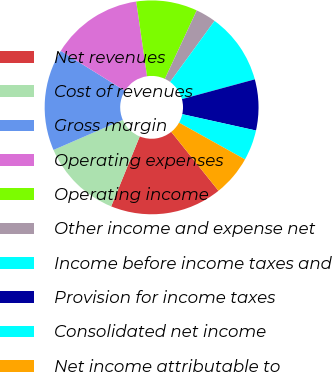<chart> <loc_0><loc_0><loc_500><loc_500><pie_chart><fcel>Net revenues<fcel>Cost of revenues<fcel>Gross margin<fcel>Operating expenses<fcel>Operating income<fcel>Other income and expense net<fcel>Income before income taxes and<fcel>Provision for income taxes<fcel>Consolidated net income<fcel>Net income attributable to<nl><fcel>16.92%<fcel>12.31%<fcel>15.38%<fcel>13.85%<fcel>9.23%<fcel>3.08%<fcel>10.77%<fcel>7.69%<fcel>4.62%<fcel>6.15%<nl></chart> 